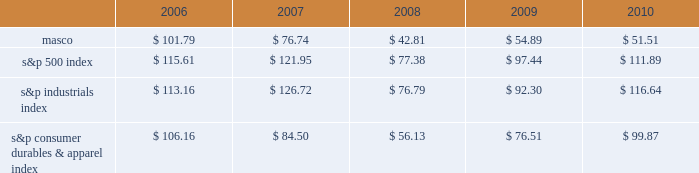Performance graph the table below compares the cumulative total shareholder return on our common stock with the cumulative total return of ( i ) the standard & poor 2019s 500 composite stock index ( 201cs&p 500 index 201d ) , ( ii ) the standard & poor 2019s industrials index ( 201cs&p industrials index 201d ) and ( iii ) the standard & poor 2019s consumer durables & apparel index ( 201cs&p consumer durables & apparel index 201d ) , from december 31 , 2005 through december 31 , 2010 , when the closing price of our common stock was $ 12.66 .
The graph assumes investments of $ 100 on december 31 , 2005 in our common stock and in each of the three indices and the reinvestment of dividends .
Performance graph 201020092008200720062005 s&p 500 index s&p industrials index s&p consumer durables & apparel index the table below sets forth the value , as of december 31 for each of the years indicated , of a $ 100 investment made on december 31 , 2005 in each of our common stock , the s&p 500 index , the s&p industrials index and the s&p consumer durables & apparel index and includes the reinvestment of dividends. .
In july 2007 , our board of directors authorized the purchase of up to 50 million shares of our common stock in open-market transactions or otherwise .
At december 31 , 2010 , we had remaining authorization to repurchase up to 27 million shares .
During 2010 , we repurchased and retired three million shares of our common stock , for cash aggregating $ 45 million to offset the dilutive impact of the 2010 grant of three million shares of long-term stock awards .
We did not purchase any shares during the three months ended december 31 , 2010. .
What was the percentage cumulative total shareholder return on masco common stock for the five year period ended 2010? 
Computations: ((51.51 - 100) / 100)
Answer: -0.4849. 